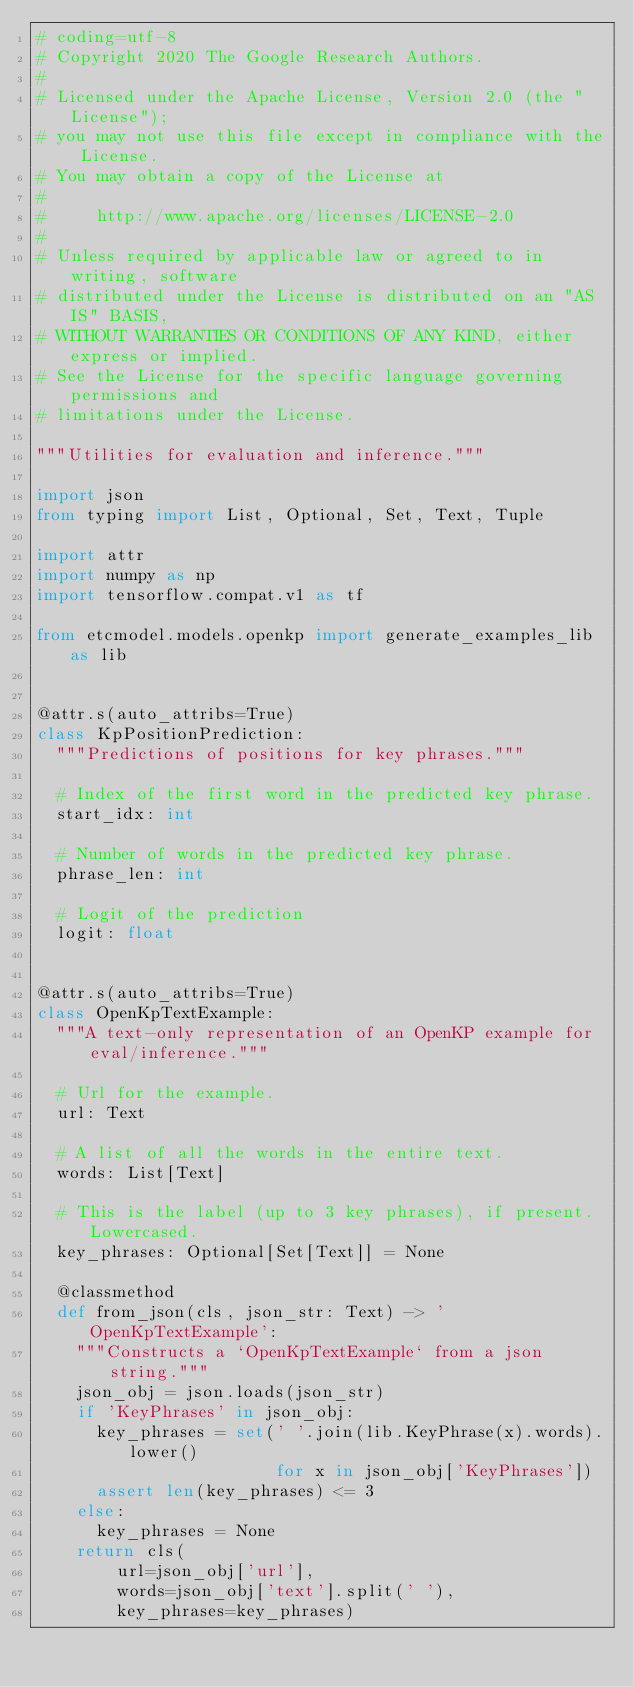Convert code to text. <code><loc_0><loc_0><loc_500><loc_500><_Python_># coding=utf-8
# Copyright 2020 The Google Research Authors.
#
# Licensed under the Apache License, Version 2.0 (the "License");
# you may not use this file except in compliance with the License.
# You may obtain a copy of the License at
#
#     http://www.apache.org/licenses/LICENSE-2.0
#
# Unless required by applicable law or agreed to in writing, software
# distributed under the License is distributed on an "AS IS" BASIS,
# WITHOUT WARRANTIES OR CONDITIONS OF ANY KIND, either express or implied.
# See the License for the specific language governing permissions and
# limitations under the License.

"""Utilities for evaluation and inference."""

import json
from typing import List, Optional, Set, Text, Tuple

import attr
import numpy as np
import tensorflow.compat.v1 as tf

from etcmodel.models.openkp import generate_examples_lib as lib


@attr.s(auto_attribs=True)
class KpPositionPrediction:
  """Predictions of positions for key phrases."""

  # Index of the first word in the predicted key phrase.
  start_idx: int

  # Number of words in the predicted key phrase.
  phrase_len: int

  # Logit of the prediction
  logit: float


@attr.s(auto_attribs=True)
class OpenKpTextExample:
  """A text-only representation of an OpenKP example for eval/inference."""

  # Url for the example.
  url: Text

  # A list of all the words in the entire text.
  words: List[Text]

  # This is the label (up to 3 key phrases), if present. Lowercased.
  key_phrases: Optional[Set[Text]] = None

  @classmethod
  def from_json(cls, json_str: Text) -> 'OpenKpTextExample':
    """Constructs a `OpenKpTextExample` from a json string."""
    json_obj = json.loads(json_str)
    if 'KeyPhrases' in json_obj:
      key_phrases = set(' '.join(lib.KeyPhrase(x).words).lower()
                        for x in json_obj['KeyPhrases'])
      assert len(key_phrases) <= 3
    else:
      key_phrases = None
    return cls(
        url=json_obj['url'],
        words=json_obj['text'].split(' '),
        key_phrases=key_phrases)
</code> 